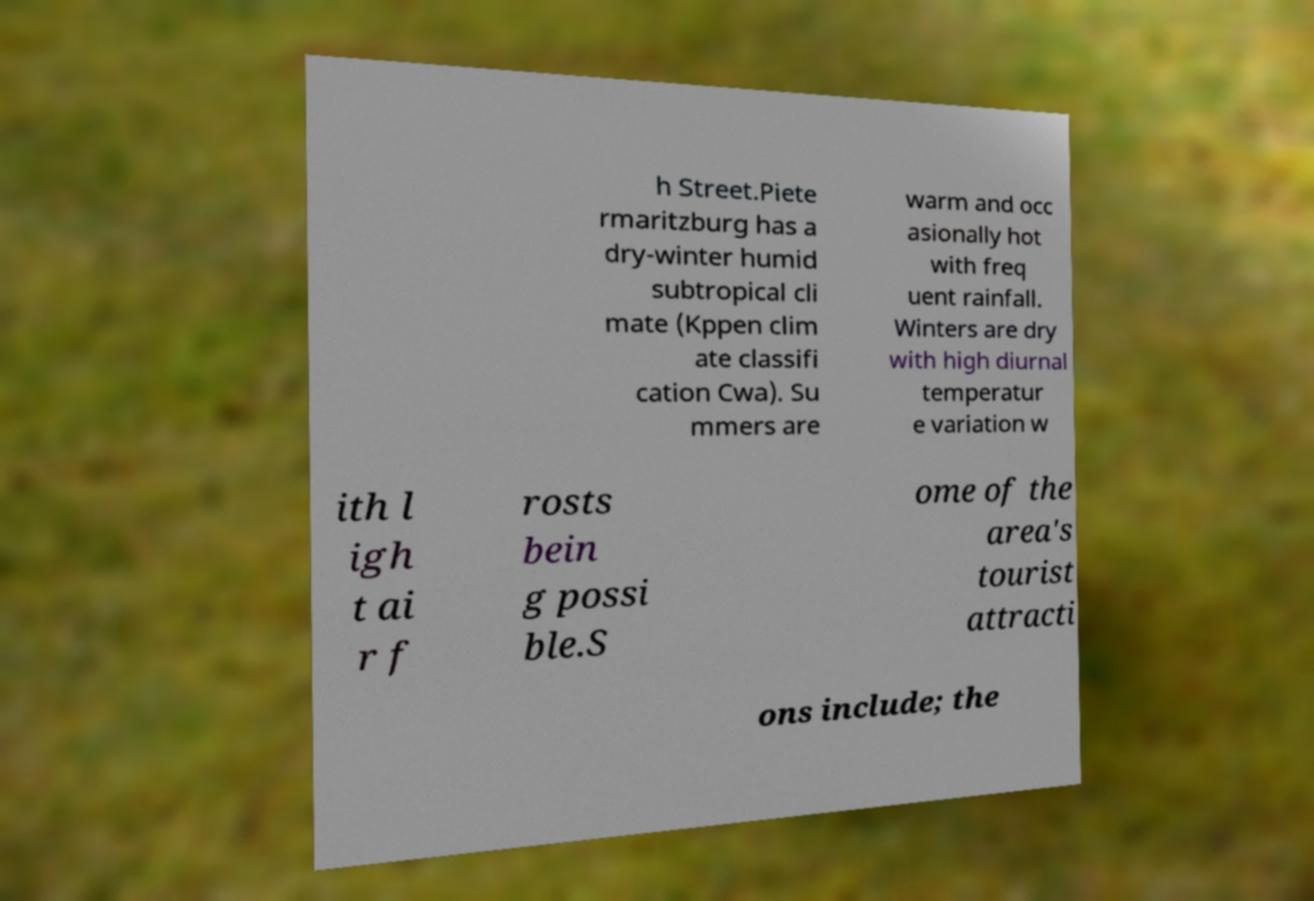What messages or text are displayed in this image? I need them in a readable, typed format. h Street.Piete rmaritzburg has a dry-winter humid subtropical cli mate (Kppen clim ate classifi cation Cwa). Su mmers are warm and occ asionally hot with freq uent rainfall. Winters are dry with high diurnal temperatur e variation w ith l igh t ai r f rosts bein g possi ble.S ome of the area's tourist attracti ons include; the 